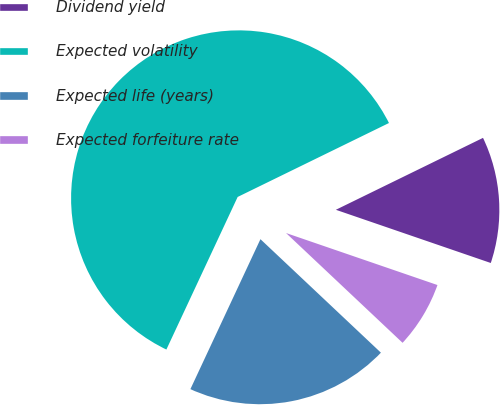Convert chart. <chart><loc_0><loc_0><loc_500><loc_500><pie_chart><fcel>Dividend yield<fcel>Expected volatility<fcel>Expected life (years)<fcel>Expected forfeiture rate<nl><fcel>12.5%<fcel>60.81%<fcel>19.93%<fcel>6.76%<nl></chart> 